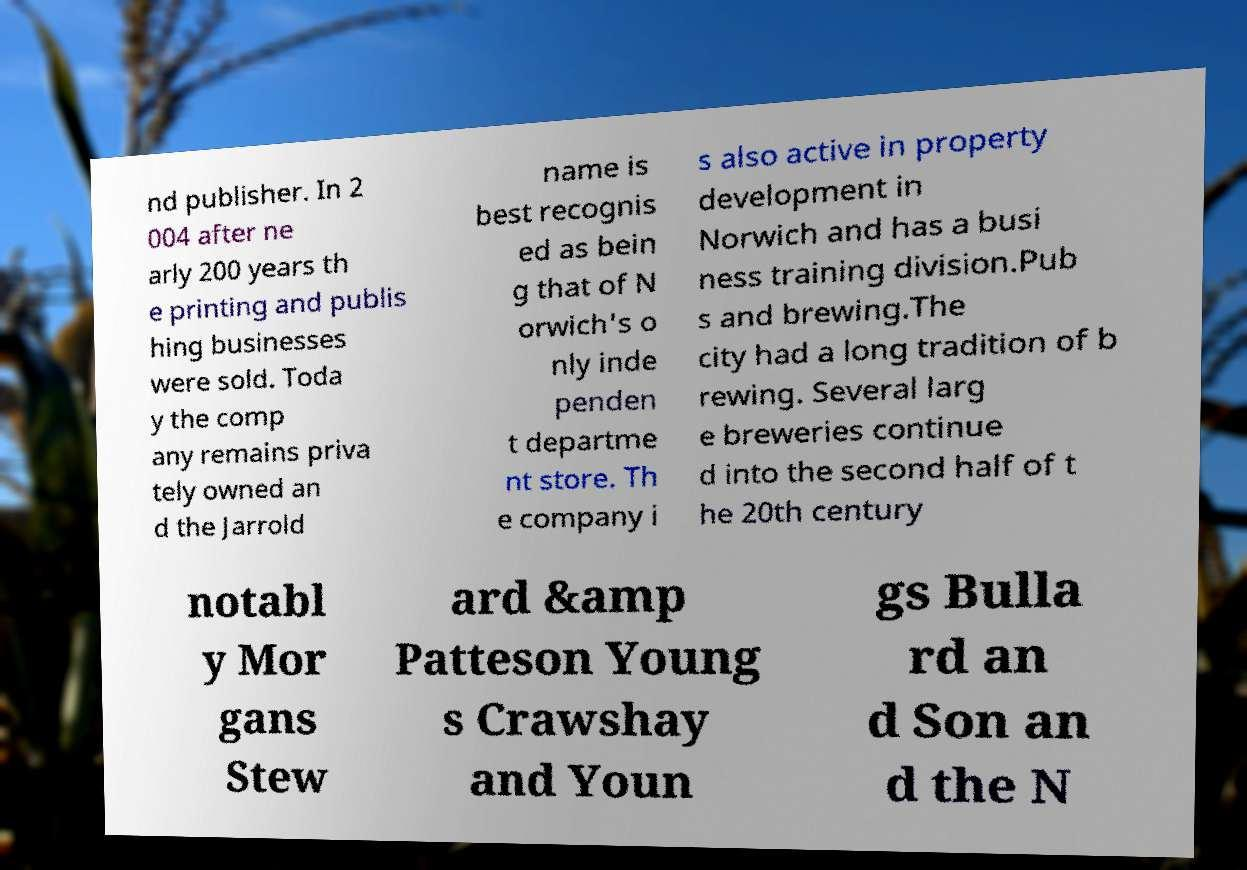Could you extract and type out the text from this image? nd publisher. In 2 004 after ne arly 200 years th e printing and publis hing businesses were sold. Toda y the comp any remains priva tely owned an d the Jarrold name is best recognis ed as bein g that of N orwich's o nly inde penden t departme nt store. Th e company i s also active in property development in Norwich and has a busi ness training division.Pub s and brewing.The city had a long tradition of b rewing. Several larg e breweries continue d into the second half of t he 20th century notabl y Mor gans Stew ard &amp Patteson Young s Crawshay and Youn gs Bulla rd an d Son an d the N 